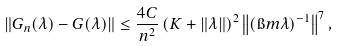<formula> <loc_0><loc_0><loc_500><loc_500>\| G _ { n } ( \lambda ) - G ( \lambda ) \| \leq \frac { 4 C } { n ^ { 2 } } \left ( K + \| \lambda \| \right ) ^ { 2 } \left \| ( \i m \lambda ) ^ { - 1 } \right \| ^ { 7 } ,</formula> 